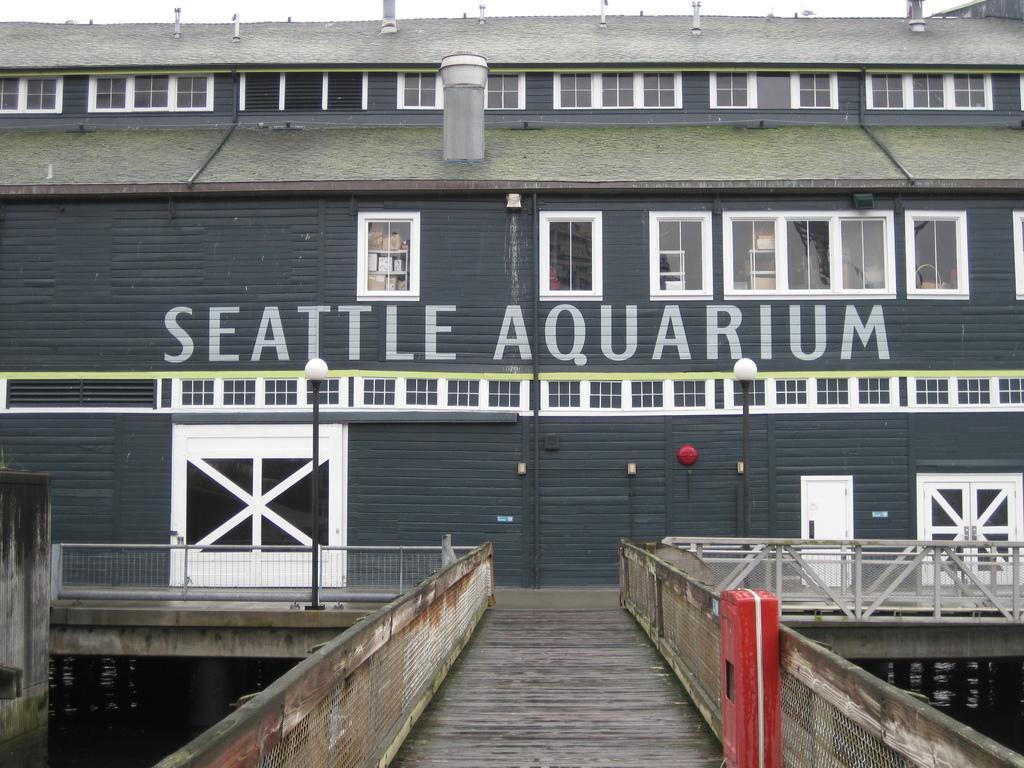Describe this image in one or two sentences. In this image I can see building,glass windows,light-poles,fencing and doors. In front I can see a red color object. 